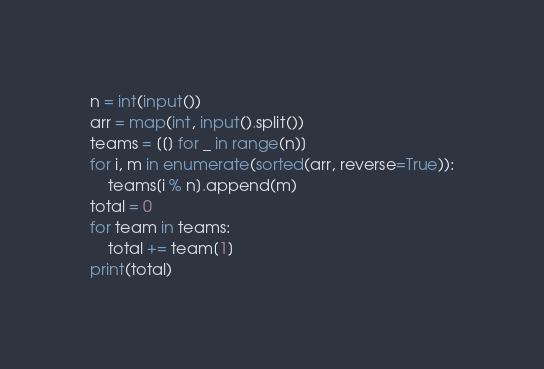Convert code to text. <code><loc_0><loc_0><loc_500><loc_500><_Python_>n = int(input())
arr = map(int, input().split())
teams = [[] for _ in range(n)]
for i, m in enumerate(sorted(arr, reverse=True)):
    teams[i % n].append(m)
total = 0
for team in teams:
    total += team[1]
print(total)</code> 